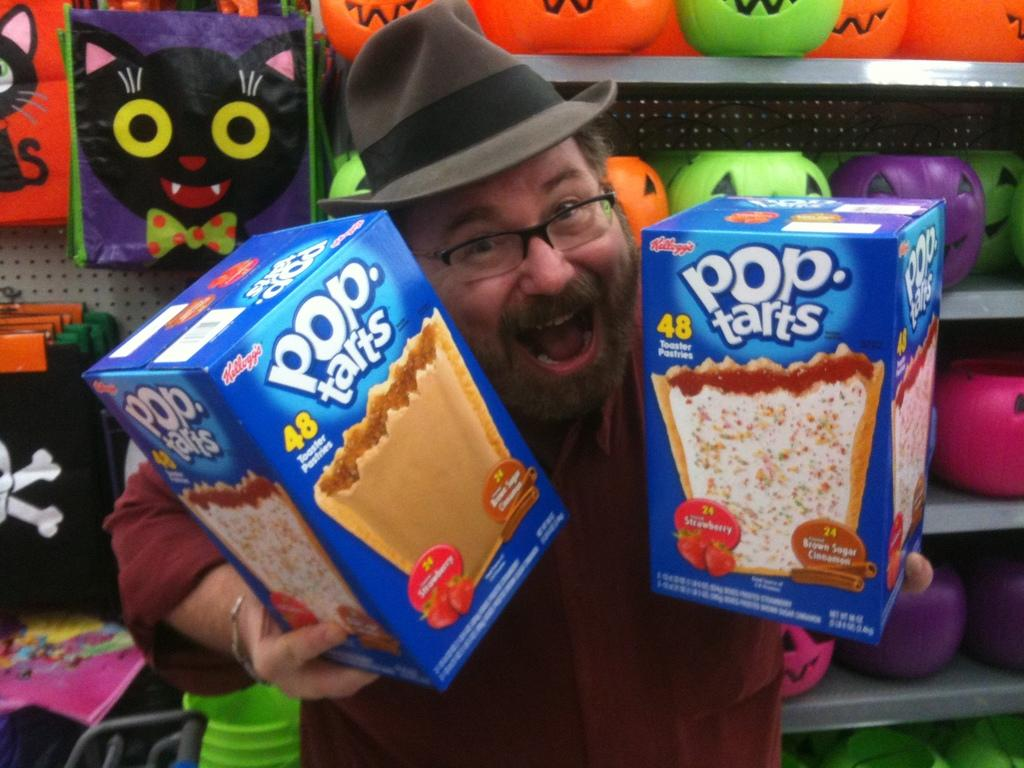Who is the main subject in the image? There is a man in the image. What is the man holding in the image? The man is holding snack boxes. What else can be seen in the background of the image? There are toys and bags visible behind the man. What type of parent is the man in the image? There is no information about the man's parenting status in the image. 